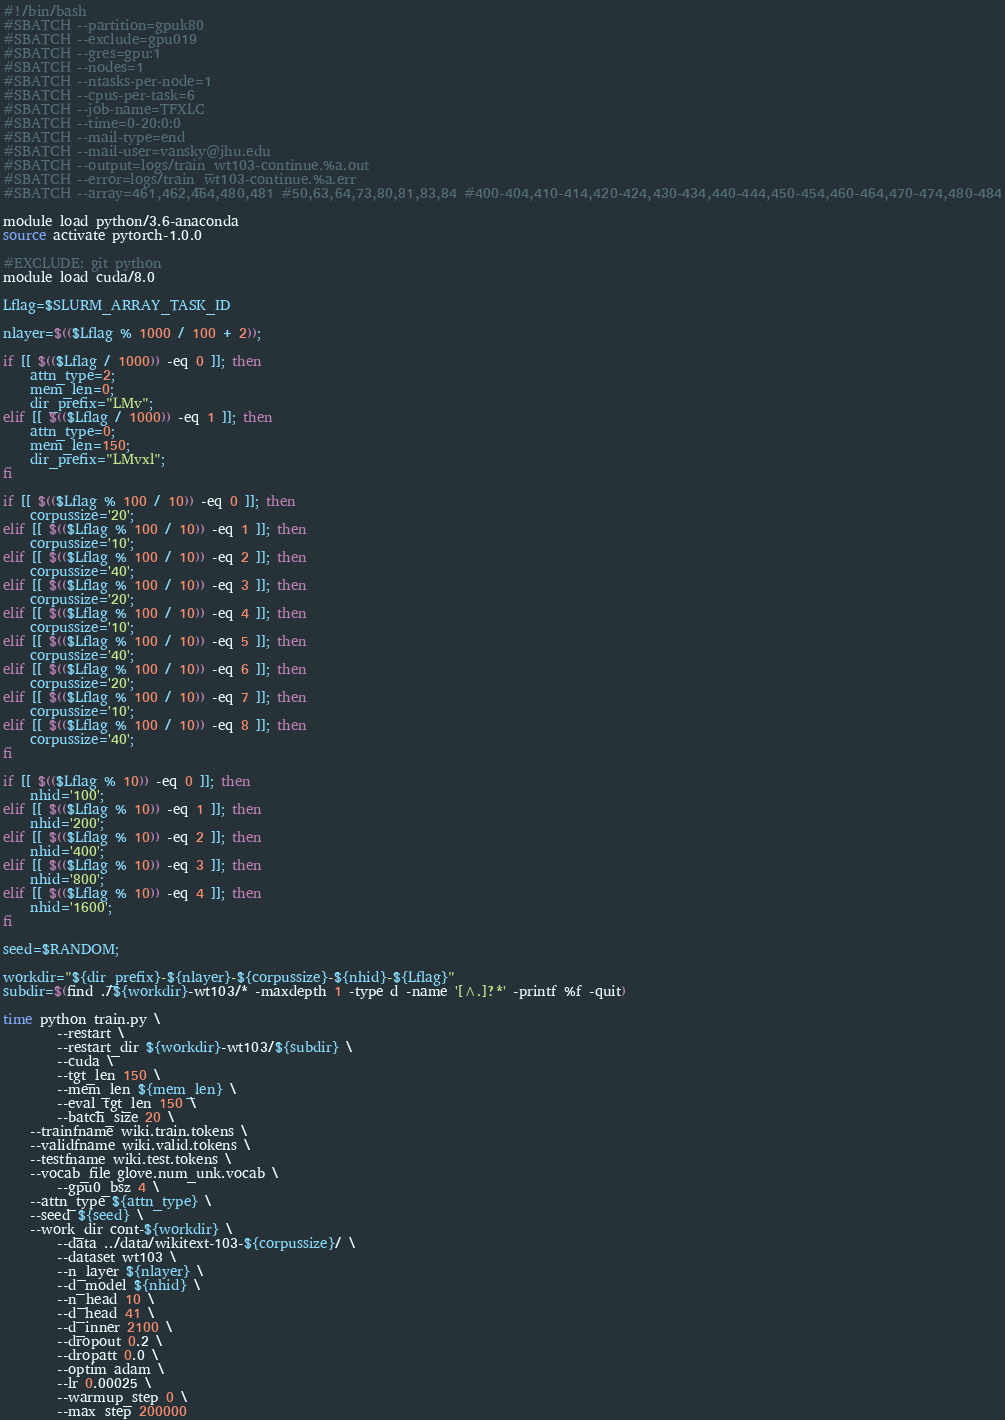Convert code to text. <code><loc_0><loc_0><loc_500><loc_500><_Bash_>#!/bin/bash
#SBATCH --partition=gpuk80
#SBATCH --exclude=gpu019
#SBATCH --gres=gpu:1
#SBATCH --nodes=1
#SBATCH --ntasks-per-node=1
#SBATCH --cpus-per-task=6
#SBATCH --job-name=TFXLC
#SBATCH --time=0-20:0:0
#SBATCH --mail-type=end
#SBATCH --mail-user=vansky@jhu.edu
#SBATCH --output=logs/train_wt103-continue.%a.out
#SBATCH --error=logs/train_wt103-continue.%a.err
#SBATCH --array=461,462,464,480,481 #50,63,64,73,80,81,83,84 #400-404,410-414,420-424,430-434,440-444,450-454,460-464,470-474,480-484

module load python/3.6-anaconda
source activate pytorch-1.0.0

#EXCLUDE: git python
module load cuda/8.0

Lflag=$SLURM_ARRAY_TASK_ID

nlayer=$(($Lflag % 1000 / 100 + 2));

if [[ $(($Lflag / 1000)) -eq 0 ]]; then
    attn_type=2;
    mem_len=0;
    dir_prefix="LMv";
elif [[ $(($Lflag / 1000)) -eq 1 ]]; then
    attn_type=0;
    mem_len=150;
    dir_prefix="LMvxl";
fi

if [[ $(($Lflag % 100 / 10)) -eq 0 ]]; then
    corpussize='20';
elif [[ $(($Lflag % 100 / 10)) -eq 1 ]]; then
    corpussize='10';
elif [[ $(($Lflag % 100 / 10)) -eq 2 ]]; then
    corpussize='40';
elif [[ $(($Lflag % 100 / 10)) -eq 3 ]]; then
    corpussize='20';
elif [[ $(($Lflag % 100 / 10)) -eq 4 ]]; then
    corpussize='10';
elif [[ $(($Lflag % 100 / 10)) -eq 5 ]]; then
    corpussize='40';
elif [[ $(($Lflag % 100 / 10)) -eq 6 ]]; then
    corpussize='20';
elif [[ $(($Lflag % 100 / 10)) -eq 7 ]]; then
    corpussize='10';
elif [[ $(($Lflag % 100 / 10)) -eq 8 ]]; then
    corpussize='40';
fi

if [[ $(($Lflag % 10)) -eq 0 ]]; then
    nhid='100';
elif [[ $(($Lflag % 10)) -eq 1 ]]; then
    nhid='200';
elif [[ $(($Lflag % 10)) -eq 2 ]]; then
    nhid='400';
elif [[ $(($Lflag % 10)) -eq 3 ]]; then
    nhid='800';
elif [[ $(($Lflag % 10)) -eq 4 ]]; then
    nhid='1600';
fi

seed=$RANDOM;

workdir="${dir_prefix}-${nlayer}-${corpussize}-${nhid}-${Lflag}"
subdir=$(find ./${workdir}-wt103/* -maxdepth 1 -type d -name '[^.]?*' -printf %f -quit)

time python train.py \
        --restart \
        --restart_dir ${workdir}-wt103/${subdir} \
        --cuda \
        --tgt_len 150 \
        --mem_len ${mem_len} \
        --eval_tgt_len 150 \
        --batch_size 20 \
	--trainfname wiki.train.tokens \
	--validfname wiki.valid.tokens \
	--testfname wiki.test.tokens \
	--vocab_file glove.num_unk.vocab \
        --gpu0_bsz 4 \
	--attn_type ${attn_type} \
	--seed ${seed} \
	--work_dir cont-${workdir} \
        --data ../data/wikitext-103-${corpussize}/ \
        --dataset wt103 \
        --n_layer ${nlayer} \
        --d_model ${nhid} \
        --n_head 10 \
        --d_head 41 \
        --d_inner 2100 \
        --dropout 0.2 \
        --dropatt 0.0 \
        --optim adam \
        --lr 0.00025 \
        --warmup_step 0 \
        --max_step 200000
</code> 